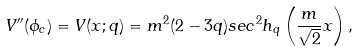Convert formula to latex. <formula><loc_0><loc_0><loc_500><loc_500>V ^ { \prime \prime } ( \phi _ { c } ) = V ( x ; q ) = m ^ { 2 } ( 2 - 3 q ) s e c ^ { 2 } h _ { q } \left ( \frac { m } { \sqrt { 2 } } x \right ) ,</formula> 